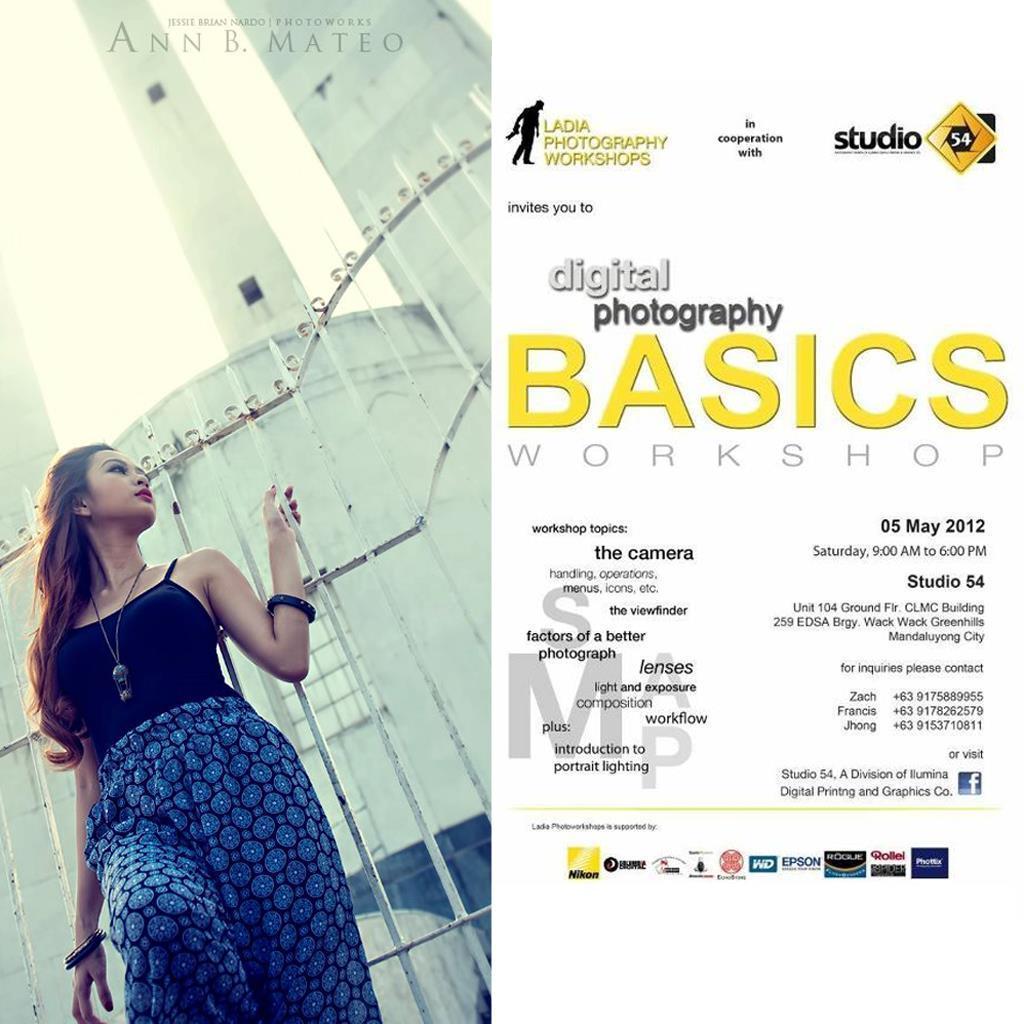Describe this image in one or two sentences. On the right side of the picture we can see a poster with some information. On the left side we can see a woman standing near to the fence, holding a grill. At the top we can see a watermark. In the background we can see a building. 